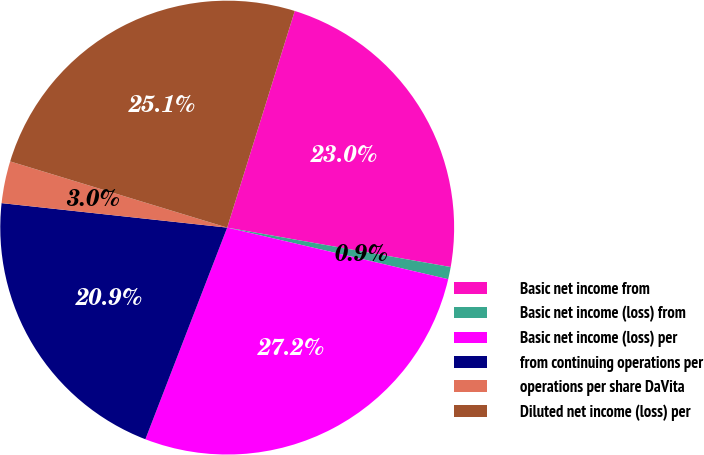<chart> <loc_0><loc_0><loc_500><loc_500><pie_chart><fcel>Basic net income from<fcel>Basic net income (loss) from<fcel>Basic net income (loss) per<fcel>from continuing operations per<fcel>operations per share DaVita<fcel>Diluted net income (loss) per<nl><fcel>22.97%<fcel>0.87%<fcel>27.22%<fcel>20.85%<fcel>2.99%<fcel>25.1%<nl></chart> 